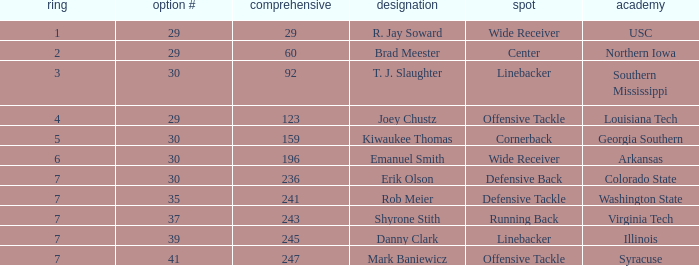What is the average Round for wide receiver r. jay soward and Overall smaller than 29? None. 